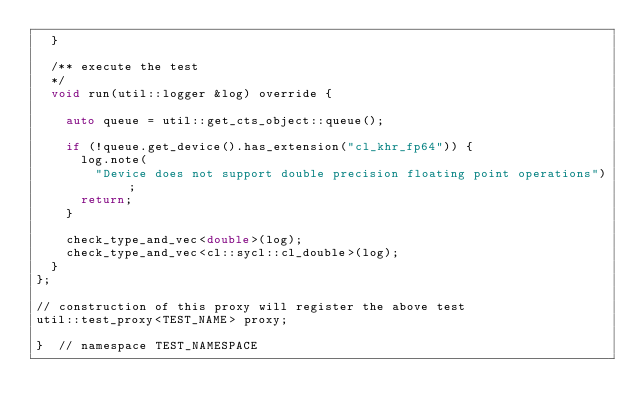<code> <loc_0><loc_0><loc_500><loc_500><_C++_>  }

  /** execute the test
  */
  void run(util::logger &log) override {

    auto queue = util::get_cts_object::queue();

    if (!queue.get_device().has_extension("cl_khr_fp64")) {
      log.note(
        "Device does not support double precision floating point operations");
      return;
    }

    check_type_and_vec<double>(log);
    check_type_and_vec<cl::sycl::cl_double>(log);
  }
};

// construction of this proxy will register the above test
util::test_proxy<TEST_NAME> proxy;

}  // namespace TEST_NAMESPACE
</code> 